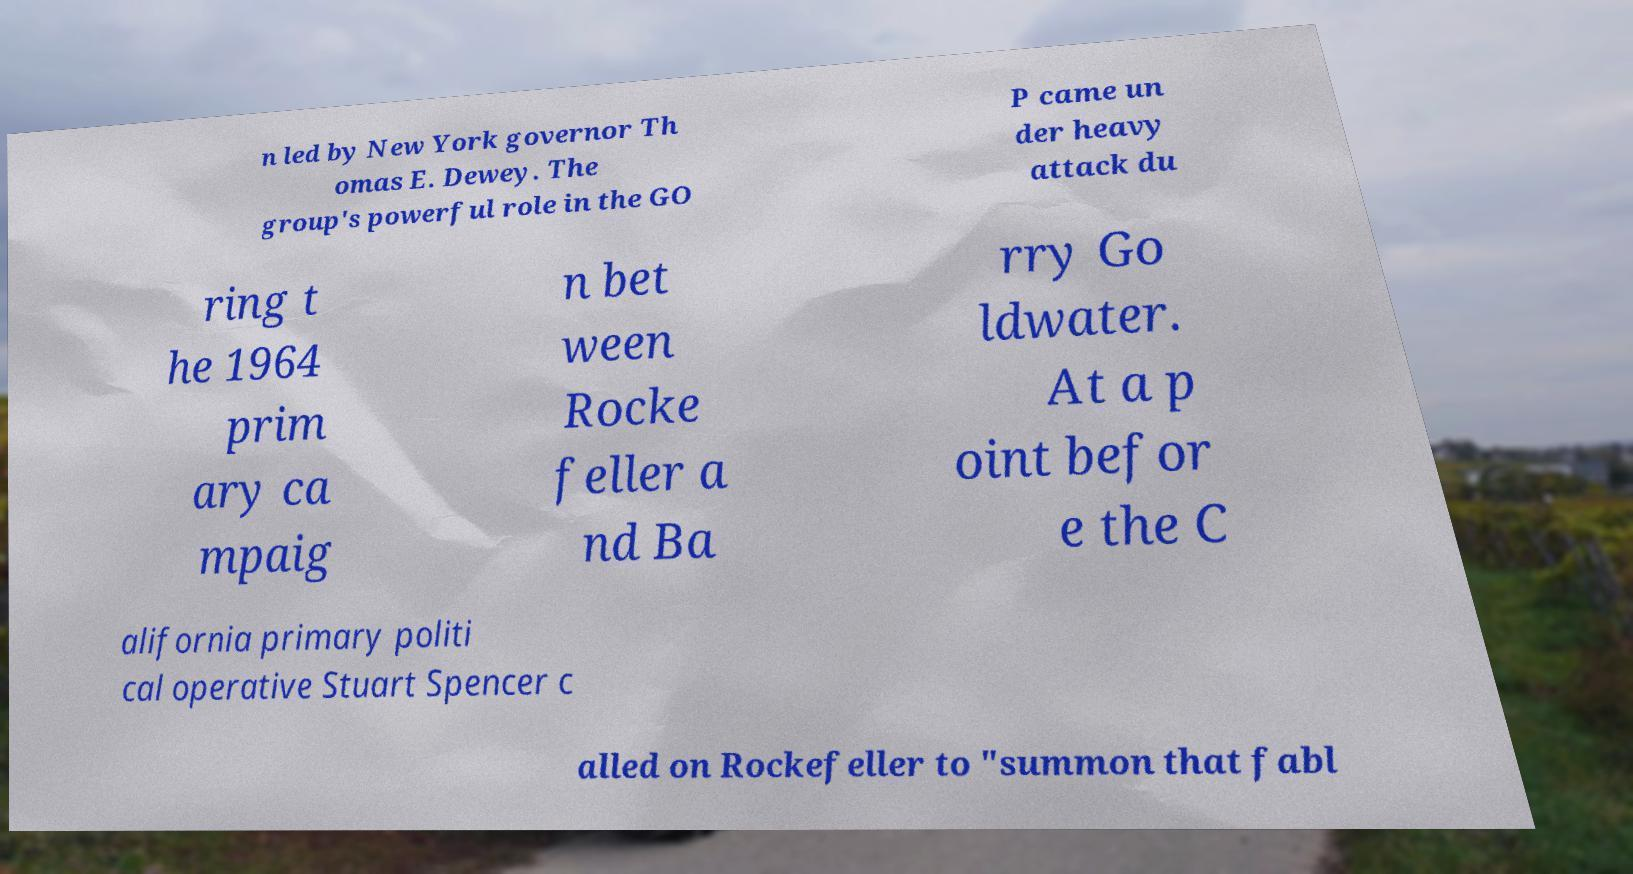I need the written content from this picture converted into text. Can you do that? n led by New York governor Th omas E. Dewey. The group's powerful role in the GO P came un der heavy attack du ring t he 1964 prim ary ca mpaig n bet ween Rocke feller a nd Ba rry Go ldwater. At a p oint befor e the C alifornia primary politi cal operative Stuart Spencer c alled on Rockefeller to "summon that fabl 